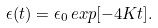<formula> <loc_0><loc_0><loc_500><loc_500>\epsilon ( t ) = \epsilon _ { 0 } \, e x p [ - 4 K t ] .</formula> 